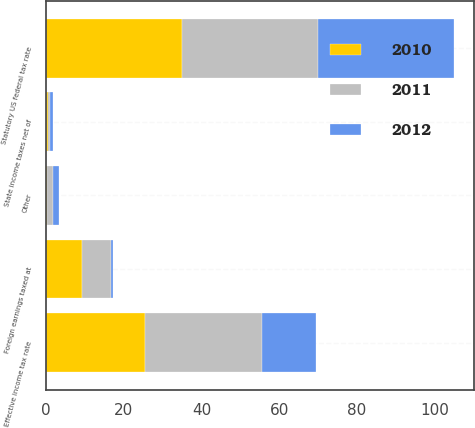<chart> <loc_0><loc_0><loc_500><loc_500><stacked_bar_chart><ecel><fcel>Statutory US federal tax rate<fcel>State income taxes net of<fcel>Foreign earnings taxed at<fcel>Other<fcel>Effective income tax rate<nl><fcel>2012<fcel>35<fcel>0.7<fcel>0.6<fcel>1.5<fcel>14<nl><fcel>2011<fcel>35<fcel>0.4<fcel>7.5<fcel>1.6<fcel>30<nl><fcel>2010<fcel>35<fcel>0.6<fcel>9.2<fcel>0.2<fcel>25.5<nl></chart> 